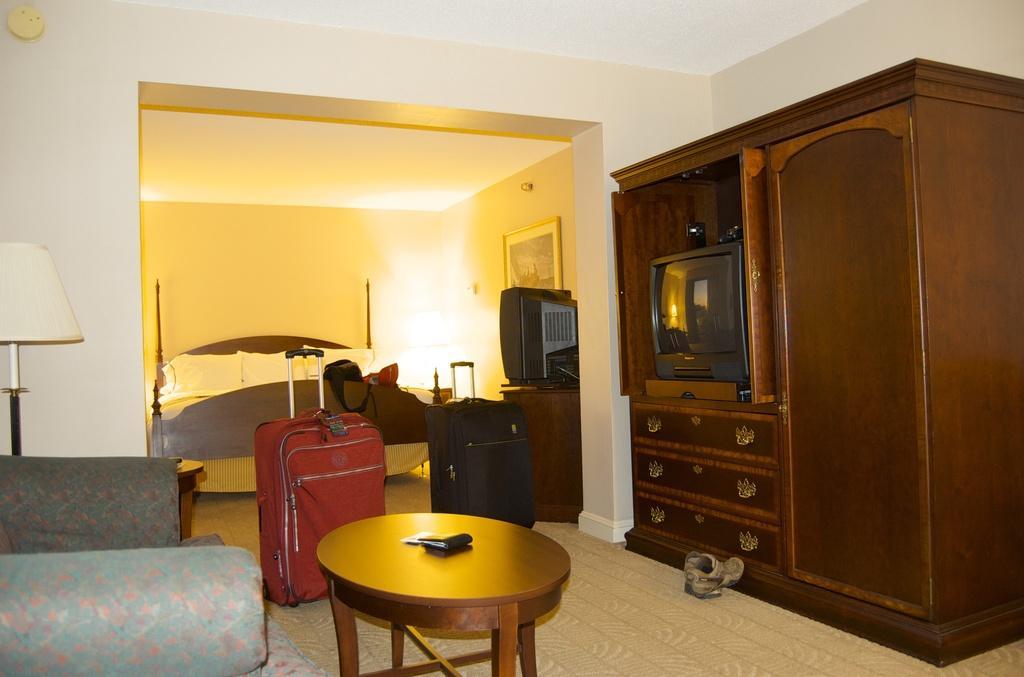Please provide a concise description of this image. In this room we can able to see a furniture with television, luggage, table, couch, lantern lamp with stand, bed with pillows and wallet. A picture on wall. 